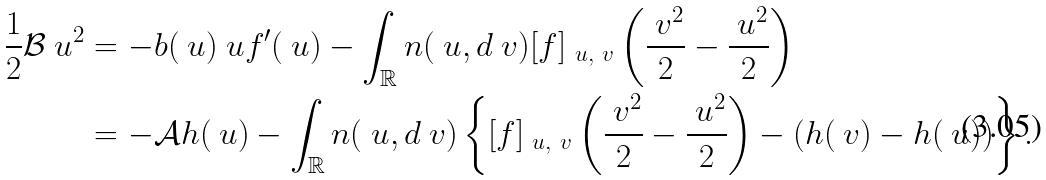Convert formula to latex. <formula><loc_0><loc_0><loc_500><loc_500>\frac { 1 } { 2 } \mathcal { B } \ u ^ { 2 } & = - b ( \ u ) \ u f ^ { \prime } ( \ u ) - \int _ { \mathbb { R } } n ( \ u , d \ v ) [ f ] _ { \ u , \ v } \left ( \frac { \ v ^ { 2 } } { 2 } - \frac { \ u ^ { 2 } } { 2 } \right ) \\ & = - \mathcal { A } h ( \ u ) - \int _ { \mathbb { R } } n ( \ u , d \ v ) \left \{ [ f ] _ { \ u , \ v } \left ( \frac { \ v ^ { 2 } } { 2 } - \frac { \ u ^ { 2 } } { 2 } \right ) - ( h ( \ v ) - h ( \ u ) ) \right \} .</formula> 